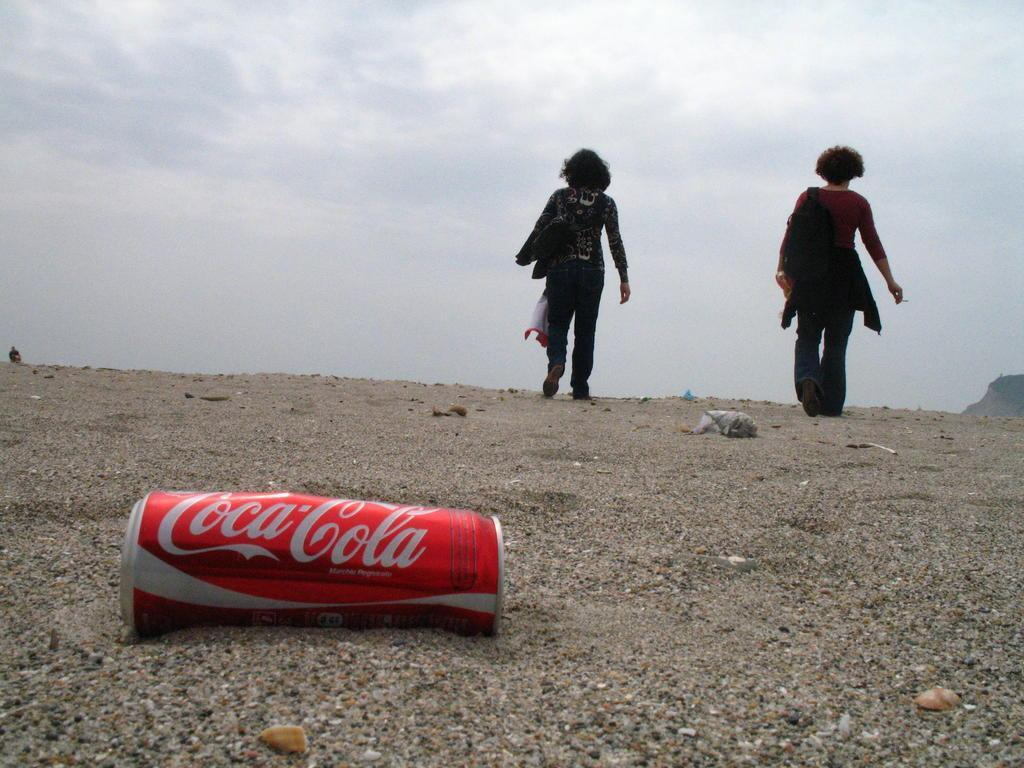What object is present in the image? There is a can in the image. Who or what is on the ground in the image? There are two persons on the ground in the image. What can be seen in the distance in the image? There is a mountain in the background of the image. What is visible above the mountain in the image? The sky is visible in the background of the image. From where was the image taken? The image appears to be taken from the ground. How much salt is present in the can in the image? There is no information about the contents of the can in the image, so we cannot determine if it contains salt or any other substance. 